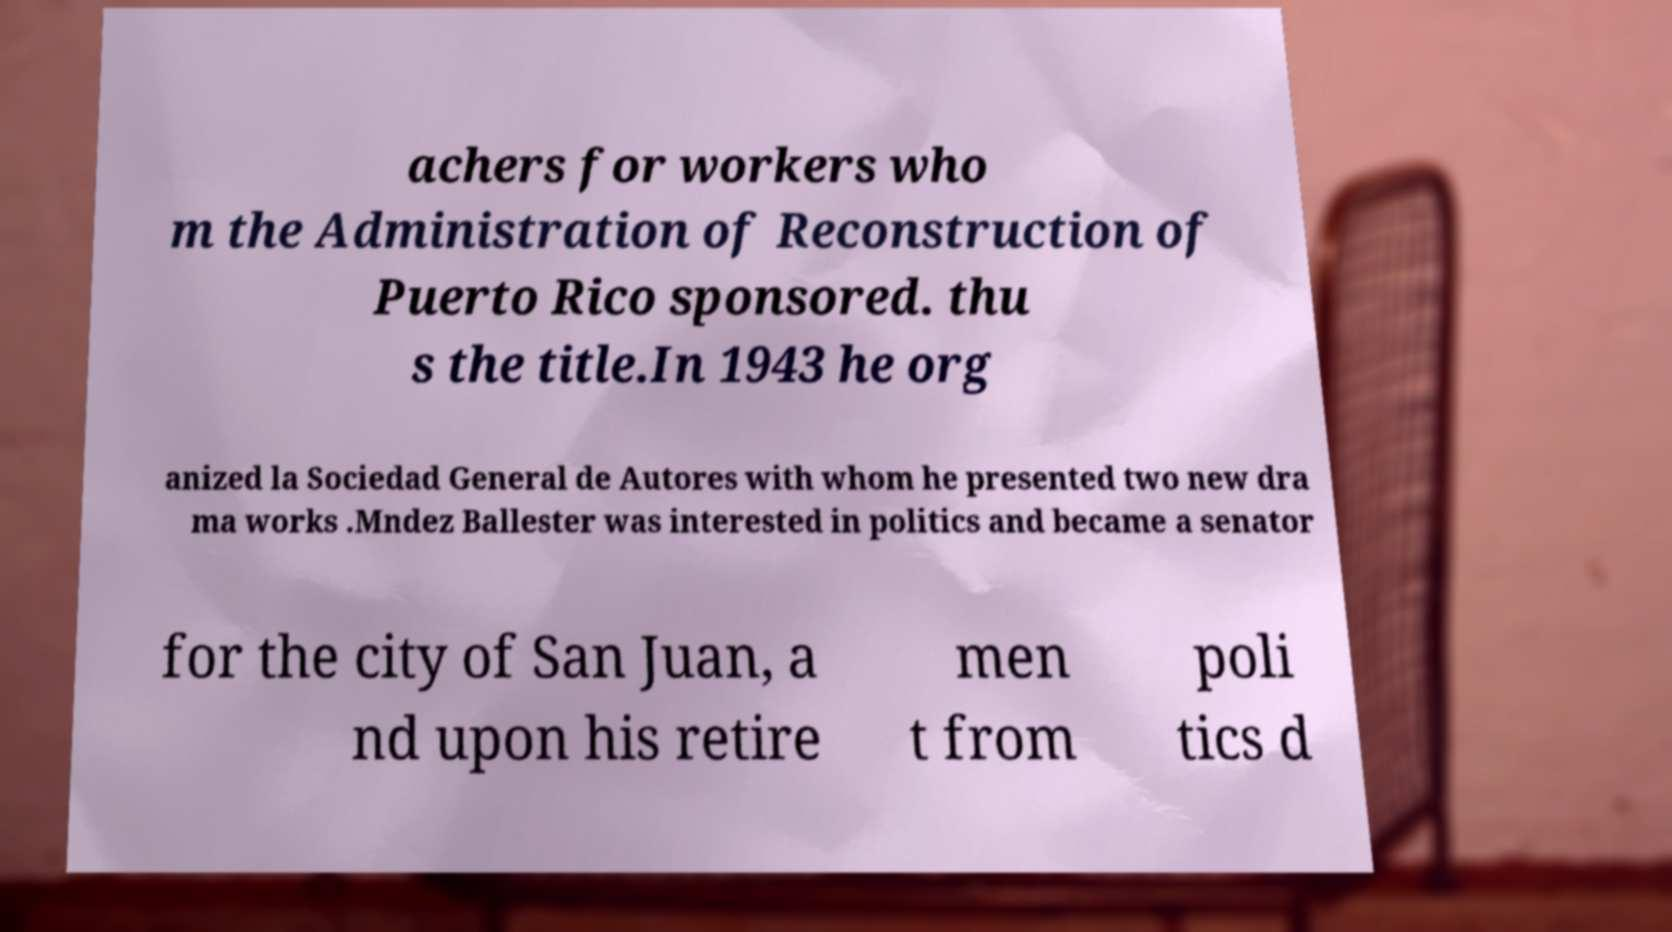Can you read and provide the text displayed in the image?This photo seems to have some interesting text. Can you extract and type it out for me? achers for workers who m the Administration of Reconstruction of Puerto Rico sponsored. thu s the title.In 1943 he org anized la Sociedad General de Autores with whom he presented two new dra ma works .Mndez Ballester was interested in politics and became a senator for the city of San Juan, a nd upon his retire men t from poli tics d 